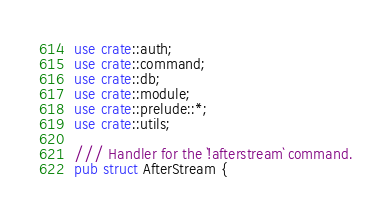<code> <loc_0><loc_0><loc_500><loc_500><_Rust_>use crate::auth;
use crate::command;
use crate::db;
use crate::module;
use crate::prelude::*;
use crate::utils;

/// Handler for the `!afterstream` command.
pub struct AfterStream {</code> 